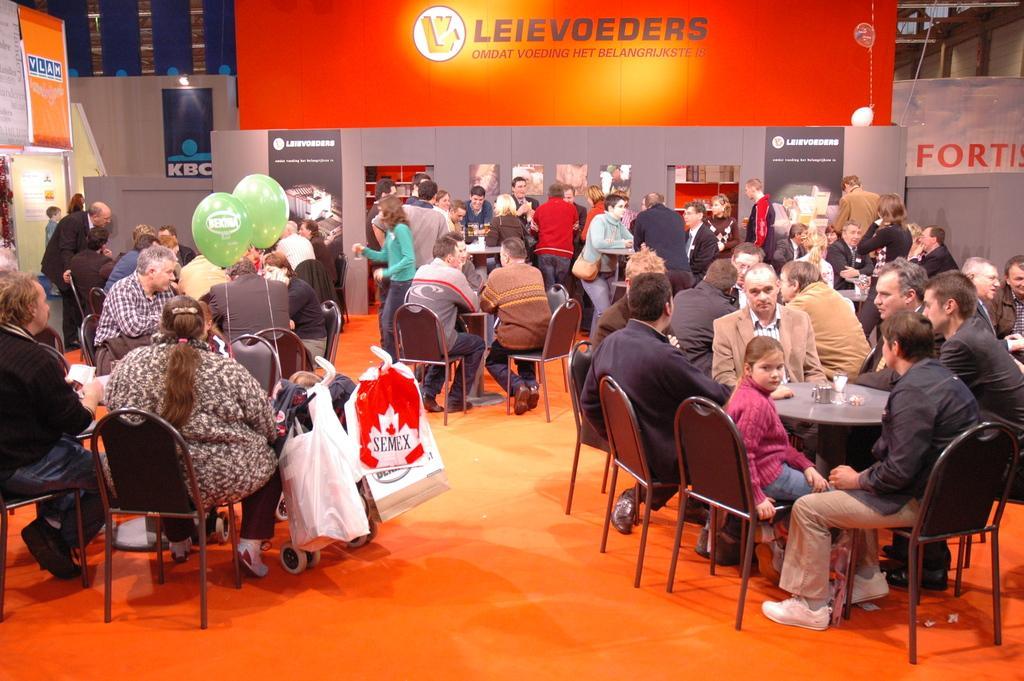Describe this image in one or two sentences. In this image I can see a group of people sitting on the chair and few people are standing at the background. In front there are two balloon the balloon is in green color and a there are some bags. On the table there are some objects. At the back side i can see a board and a banner. The board is in orange color. 